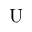Convert formula to latex. <formula><loc_0><loc_0><loc_500><loc_500>U</formula> 